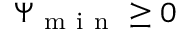Convert formula to latex. <formula><loc_0><loc_0><loc_500><loc_500>\Psi _ { m i n } \geq 0</formula> 